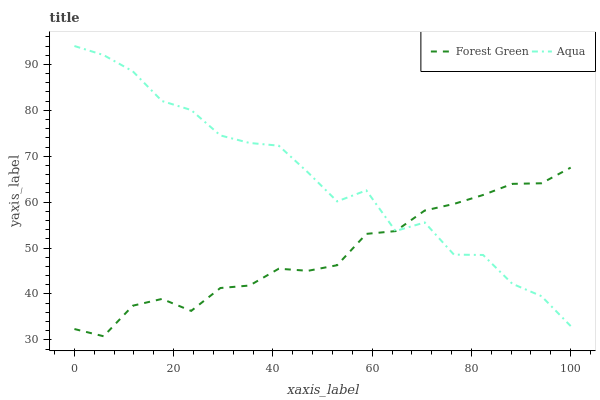Does Forest Green have the minimum area under the curve?
Answer yes or no. Yes. Does Aqua have the maximum area under the curve?
Answer yes or no. Yes. Does Aqua have the minimum area under the curve?
Answer yes or no. No. Is Forest Green the smoothest?
Answer yes or no. Yes. Is Aqua the roughest?
Answer yes or no. Yes. Is Aqua the smoothest?
Answer yes or no. No. Does Forest Green have the lowest value?
Answer yes or no. Yes. Does Aqua have the lowest value?
Answer yes or no. No. Does Aqua have the highest value?
Answer yes or no. Yes. Does Forest Green intersect Aqua?
Answer yes or no. Yes. Is Forest Green less than Aqua?
Answer yes or no. No. Is Forest Green greater than Aqua?
Answer yes or no. No. 